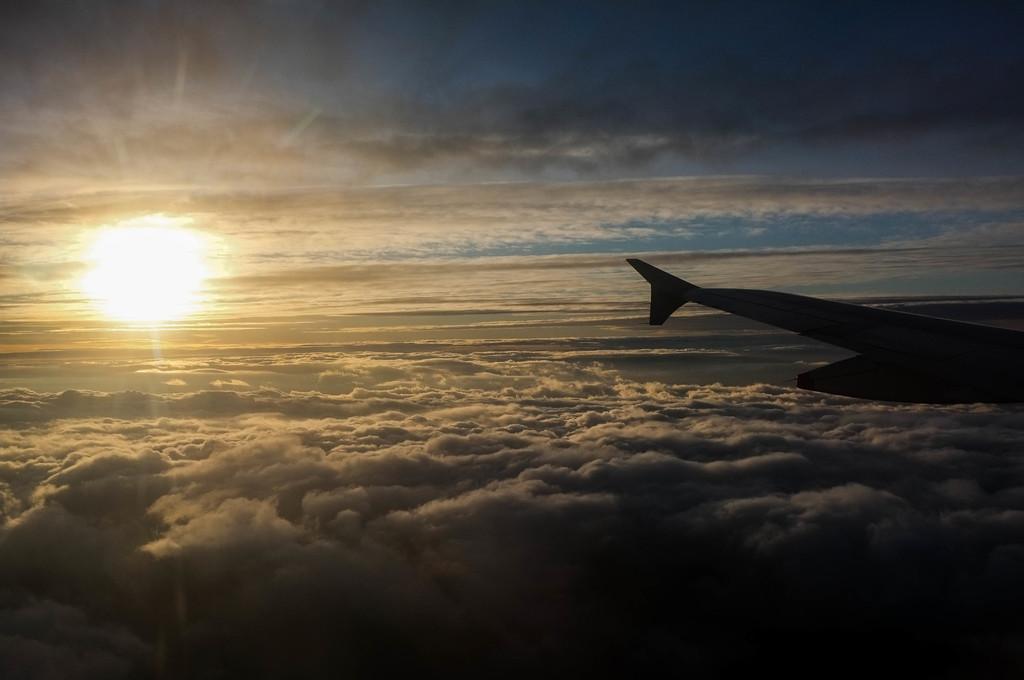How would you summarize this image in a sentence or two? In this image there is an airplane in the air. In the background of the image there are clouds, sun and sky. 